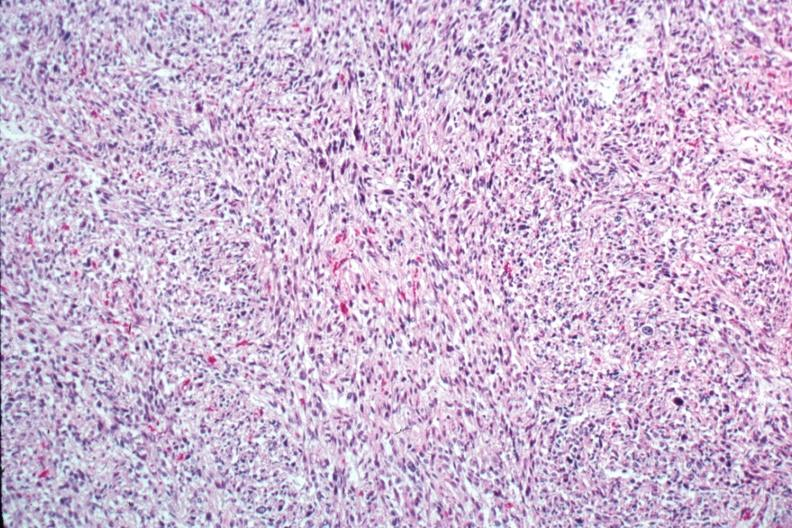does medial aspect show excellent photo of pleomorphic spindle cell tumor with storiform pattern?
Answer the question using a single word or phrase. No 